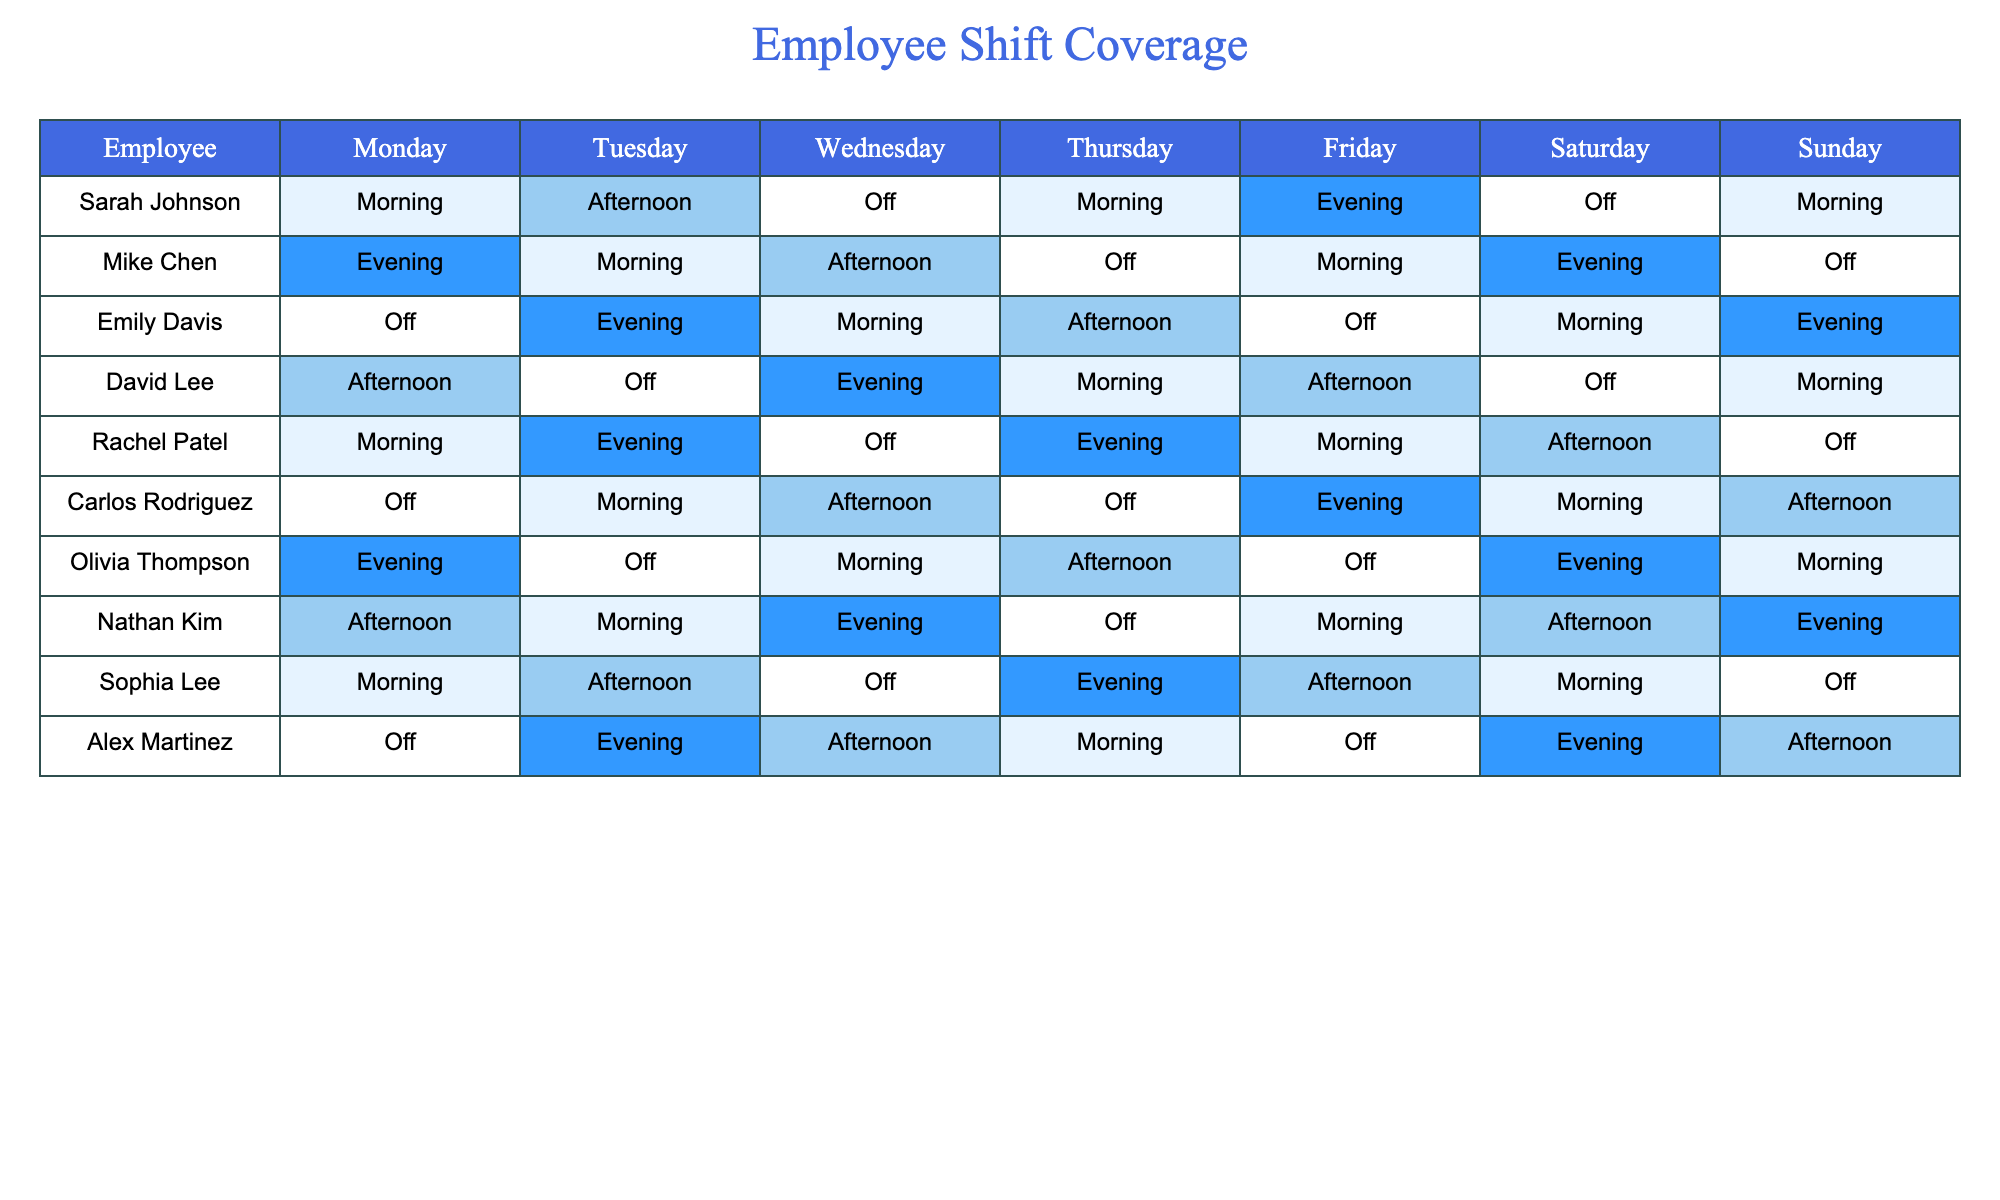What shifts does Sarah Johnson work on Friday? Referring to the table, Sarah Johnson is scheduled to work an Evening shift on Friday.
Answer: Evening How many employees have an Off shift on Tuesday? By checking the Tuesday column, Emily Davis and Olivia Thompson are listed as Off, making a total of 2 employees.
Answer: 2 Which employee has the most Evening shifts in the week? Evaluating the table: Sarah Johnson has 1 Evening, Mike Chen has 2, Emily Davis has 2, David Lee has 1, Rachel Patel has 2, Carlos Rodriguez has 1, Olivia Thompson has 2, Nathan Kim has 1, Sophia Lee has 1, and Alex Martinez has 2. The maximum is 2 Evening shifts, shared by Mike Chen, Emily Davis, Rachel Patel, Olivia Thompson, and Alex Martinez.
Answer: Mike Chen, Emily Davis, Rachel Patel, Olivia Thompson, Alex Martinez On which day does Carlos Rodriguez have an Off shift? In the table, Carlos Rodriguez has an Off shift on Monday.
Answer: Monday Is there any day when all employees are working? By reviewing each day's column, there are no days where all employees are working; Mondays have 1 Off, Tuesdays have 2 Off, Wednesdays have 3 Off, Thursdays have 1 Off, Fridays have 1 Off, Saturdays have 1 Off, and Sundays have 2 Off.
Answer: No What is the total number of Off shifts across all employees for the week? Counting the Off shifts in the table: Sarah Johnson (1), Mike Chen (1), Emily Davis (2), David Lee (1), Rachel Patel (1), Carlos Rodriguez (1), Olivia Thompson (1), Nathan Kim (1), Sophia Lee (1), Alex Martinez (1) totals to 11 Off shifts.
Answer: 11 Which employee has the most diverse shift types throughout the week? Analyzing each employee's shifts reveals that Mike Chen experiences Morning, Afternoon, and Evening shifts, while others either have more Off days or fewer shift types. Thus, Mike Chen has the most shift variety.
Answer: Mike Chen How many employees work Morning shifts on Saturday? On reviewing the Saturday column, we find that Carlos Rodriguez and Sophia Lee have Morning shifts. There are 2 employees in total.
Answer: 2 On which days do Rachel Patel and Nathan Kim both work? Looking at the table, Rachel Patel works on Monday, Tuesday, Thursday, Friday, Saturday, while Nathan Kim works on Monday, Tuesday, Thursday, Friday, Saturday, and Sunday. So, they both work on Monday, Tuesday, Thursday, and Friday.
Answer: Monday, Tuesday, Thursday, Friday 